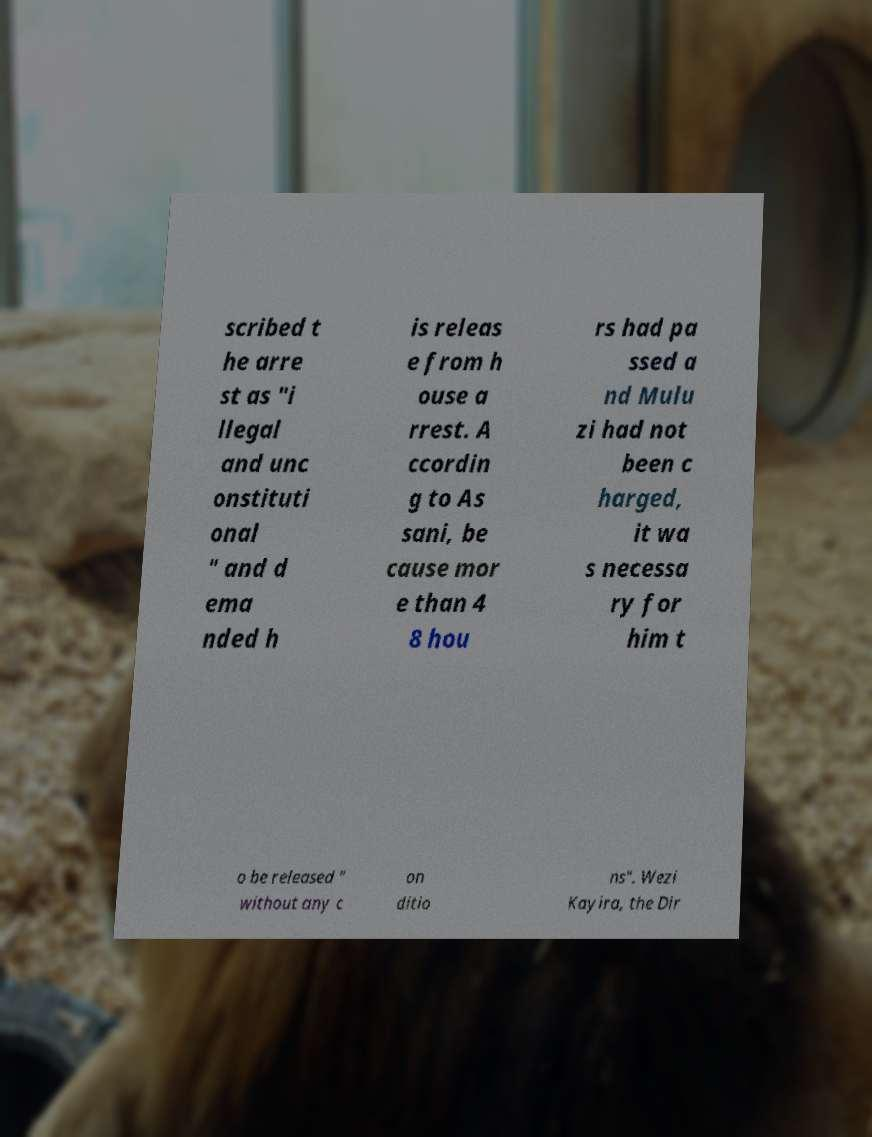Could you assist in decoding the text presented in this image and type it out clearly? scribed t he arre st as "i llegal and unc onstituti onal " and d ema nded h is releas e from h ouse a rrest. A ccordin g to As sani, be cause mor e than 4 8 hou rs had pa ssed a nd Mulu zi had not been c harged, it wa s necessa ry for him t o be released " without any c on ditio ns". Wezi Kayira, the Dir 